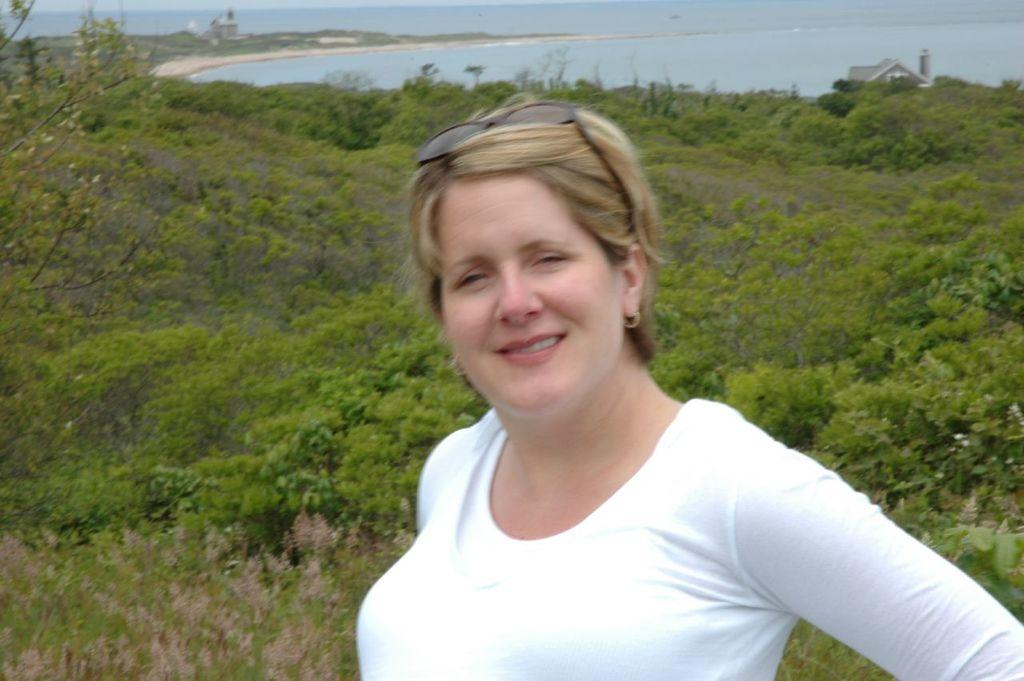What is the woman wearing in the image? The woman is wearing a white t-shirt. What is the woman's facial expression in the image? The woman is smiling. What can be seen in the background of the image? There are plants and water visible in the background. What type of structure can be seen far in the distance? There is a house far in the distance. What type of potato is being used to create the list in the image? There is no potato or list present in the image. How is the ice being used in the image? There is no ice present in the image. 